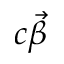<formula> <loc_0><loc_0><loc_500><loc_500>c \vec { \beta }</formula> 